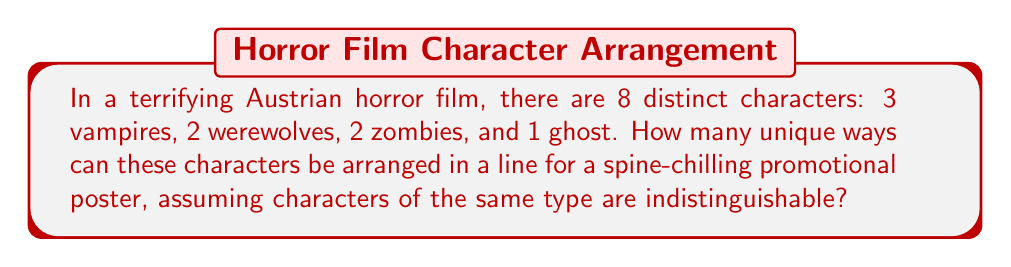Give your solution to this math problem. Let's approach this step-by-step:

1) This is a permutation problem with repeated elements. We need to use the formula for permutations with repetition:

   $$\frac{n!}{n_1! \cdot n_2! \cdot ... \cdot n_k!}$$

   Where $n$ is the total number of elements, and $n_1, n_2, ..., n_k$ are the numbers of each type of repeated element.

2) In this case:
   - Total number of characters, $n = 8$
   - Number of vampires, $n_1 = 3$
   - Number of werewolves, $n_2 = 2$
   - Number of zombies, $n_3 = 2$
   - Number of ghosts, $n_4 = 1$

3) Plugging these values into our formula:

   $$\frac{8!}{3! \cdot 2! \cdot 2! \cdot 1!}$$

4) Let's calculate this step-by-step:
   
   $8! = 40,320$
   $3! = 6$
   $2! = 2$
   $1! = 1$

5) Now our expression looks like:

   $$\frac{40,320}{6 \cdot 2 \cdot 2 \cdot 1} = \frac{40,320}{24}$$

6) Performing the division:

   $$\frac{40,320}{24} = 1,680$$

Therefore, there are 1,680 unique ways to arrange these horror movie characters.
Answer: 1,680 